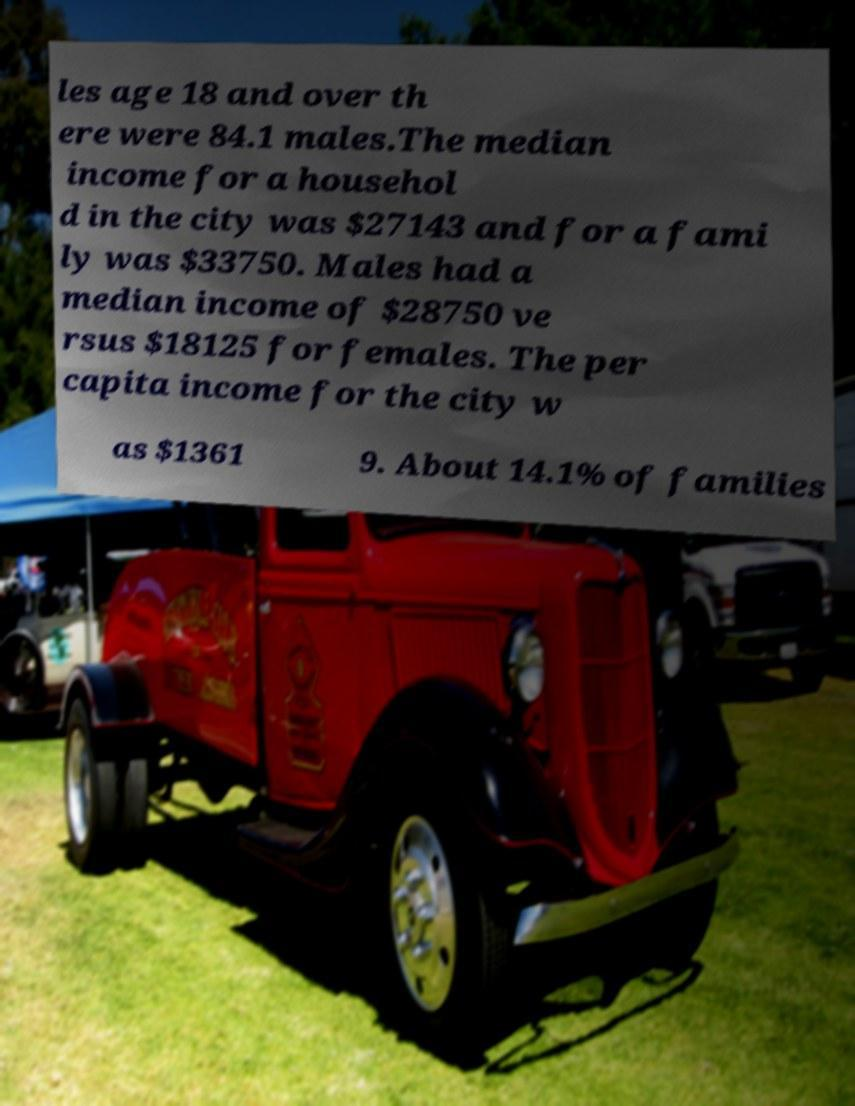Please read and relay the text visible in this image. What does it say? les age 18 and over th ere were 84.1 males.The median income for a househol d in the city was $27143 and for a fami ly was $33750. Males had a median income of $28750 ve rsus $18125 for females. The per capita income for the city w as $1361 9. About 14.1% of families 